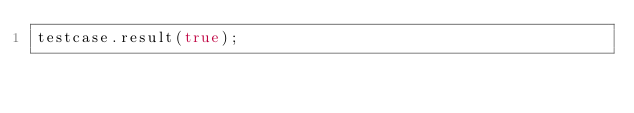Convert code to text. <code><loc_0><loc_0><loc_500><loc_500><_JavaScript_>testcase.result(true);</code> 